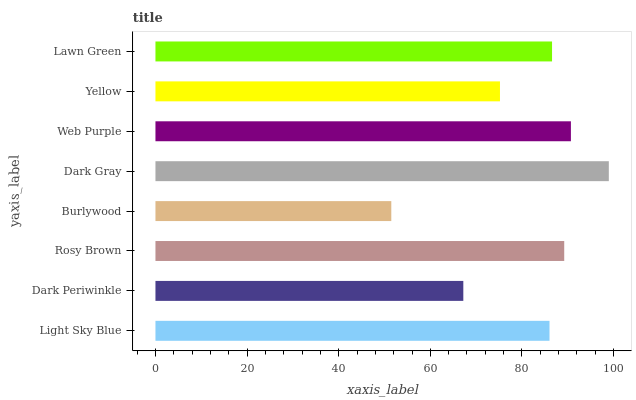Is Burlywood the minimum?
Answer yes or no. Yes. Is Dark Gray the maximum?
Answer yes or no. Yes. Is Dark Periwinkle the minimum?
Answer yes or no. No. Is Dark Periwinkle the maximum?
Answer yes or no. No. Is Light Sky Blue greater than Dark Periwinkle?
Answer yes or no. Yes. Is Dark Periwinkle less than Light Sky Blue?
Answer yes or no. Yes. Is Dark Periwinkle greater than Light Sky Blue?
Answer yes or no. No. Is Light Sky Blue less than Dark Periwinkle?
Answer yes or no. No. Is Lawn Green the high median?
Answer yes or no. Yes. Is Light Sky Blue the low median?
Answer yes or no. Yes. Is Light Sky Blue the high median?
Answer yes or no. No. Is Web Purple the low median?
Answer yes or no. No. 